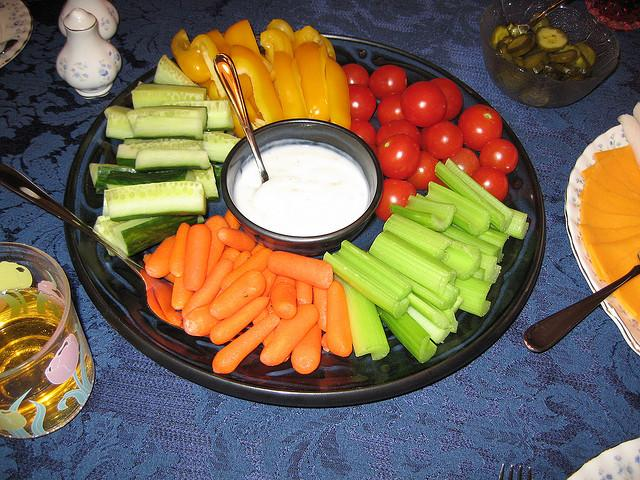What type of utensil is resting in the middle of the bowl in the cup? spoon 